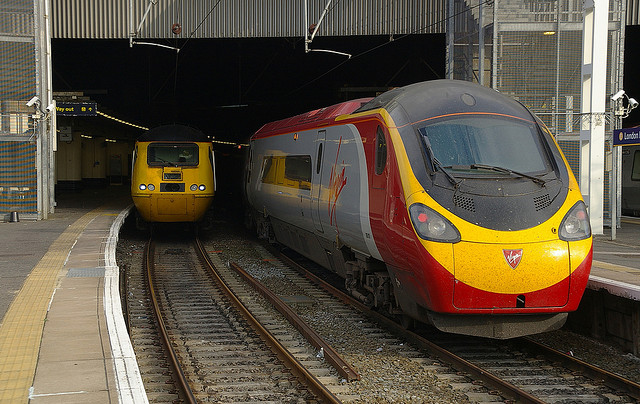How many trains are in the photo? There are two trains visible in the photo, one on the left side partially under a cover, and another on the right side clearly in view on the track. 